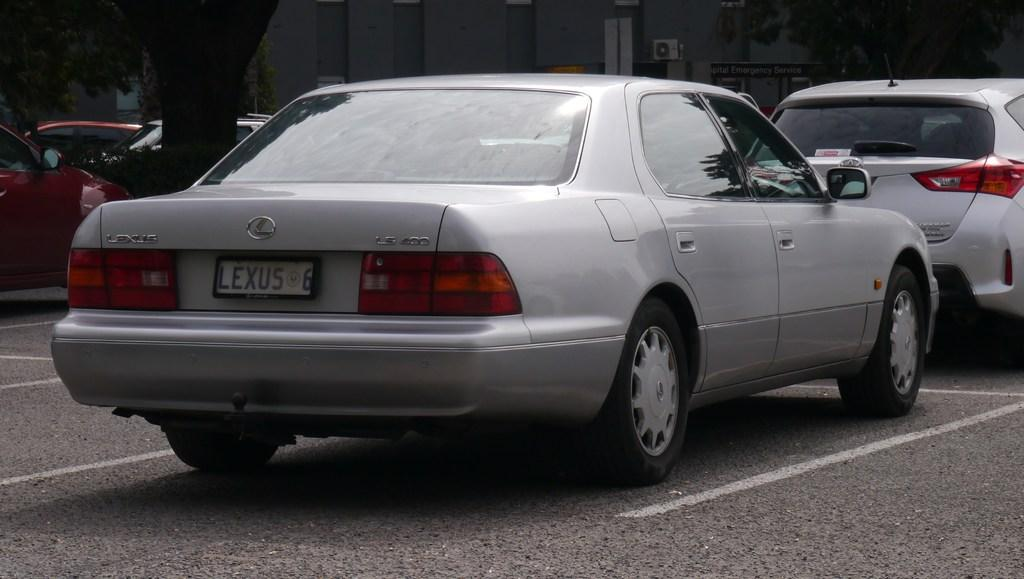Where was the picture taken? The picture was taken outside. What can be seen in the center of the image? There are many cars parked on the road in the center of the image. What is visible in the background of the image? There is a tree and a building in the background of the image. What song is being played in the background of the image? There is no indication of any song being played in the image; it only shows parked cars, a tree, and a building in the background. 